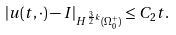<formula> <loc_0><loc_0><loc_500><loc_500>| u ( t , \cdot ) - I | _ { H ^ { \frac { 3 } { 2 } k } ( \Omega _ { 0 } ^ { + } ) } \leq C _ { 2 } t .</formula> 